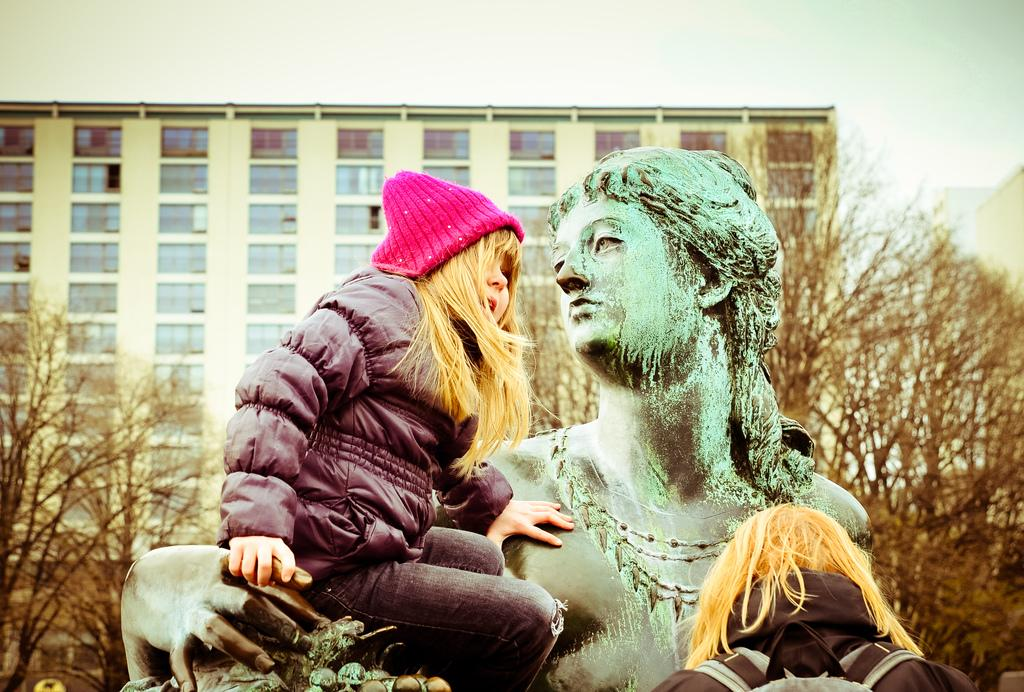What is the girl in the image wearing on her head? The girl is wearing a pink cap. What is the girl doing in the image? The girl is sitting on a statue. Can you describe another person in the image? There is another person with a bag in the image. What can be seen in the background of the image? There are trees, a building with windows, and the sky visible in the background of the image. What type of cannon is being used to control the salt in the image? There is no cannon or salt present in the image. 